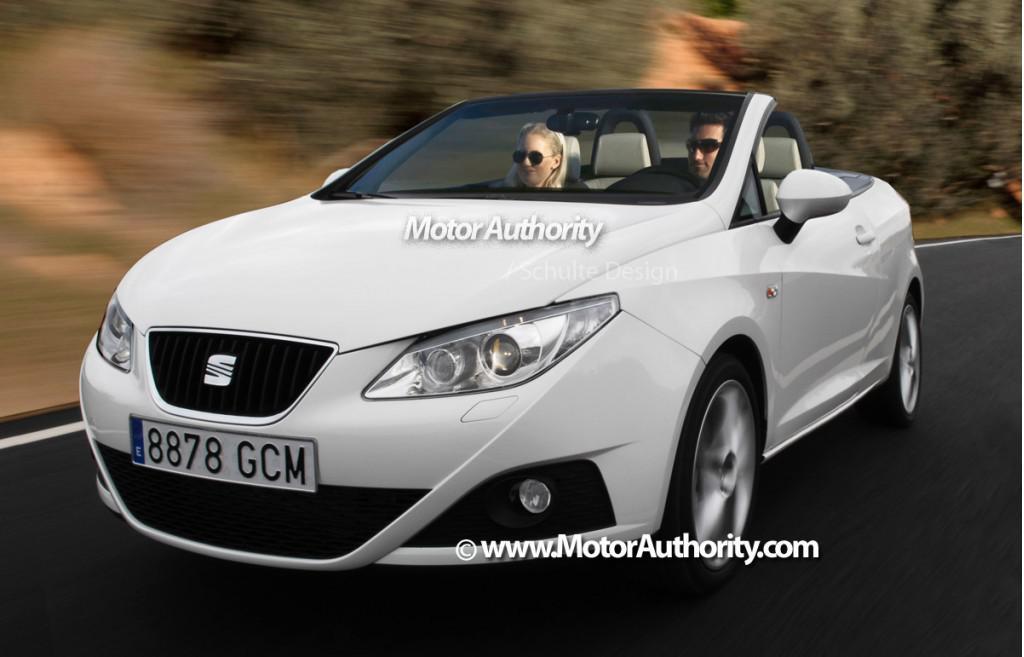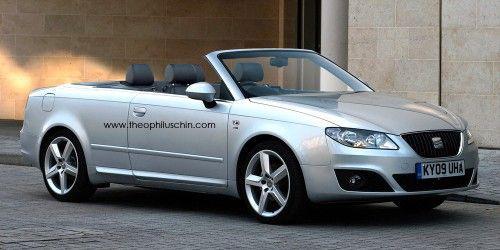The first image is the image on the left, the second image is the image on the right. Examine the images to the left and right. Is the description "An image shows the back end and tail light of a driverless white convertible with its top down." accurate? Answer yes or no. No. 